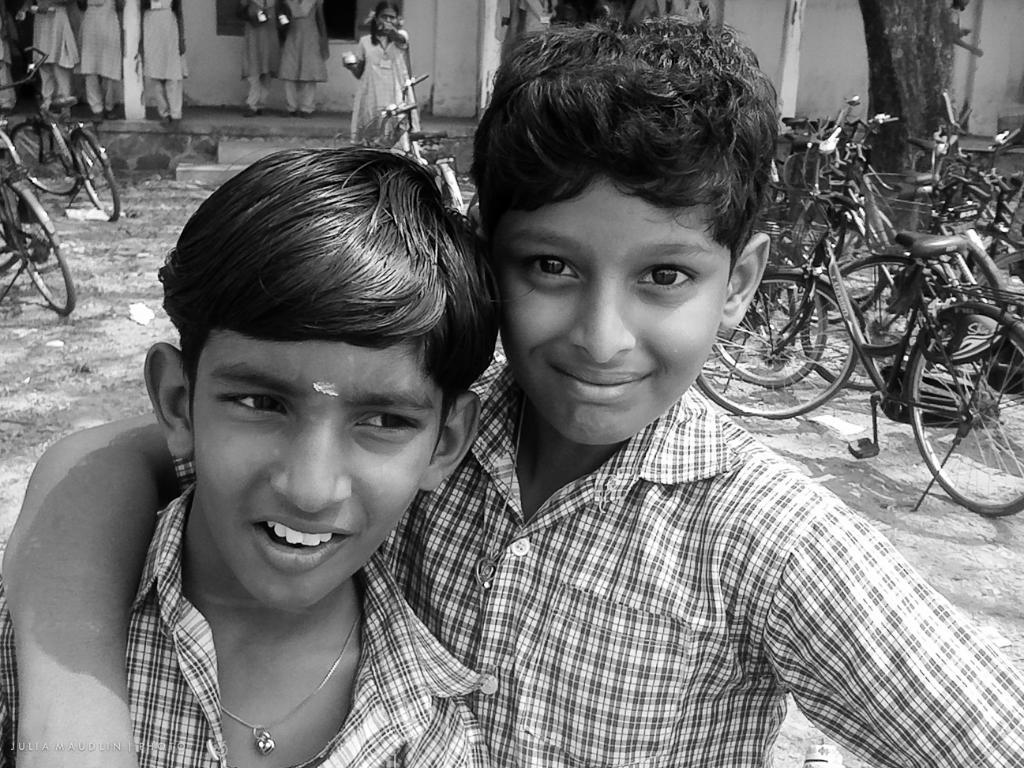What is the color scheme of the image? The image is black and white. What can be seen in the background of the image? There is a wall and people standing in the background of the image. What objects are present in the image? There are bicycles in the image. How many boys are in the image? There are two boys in the image. What are the boys wearing? The boys are wearing uniforms. What expression do the boys have? The boys are smiling. Can you tell me how many ears of corn are visible in the image? There are no ears of corn present in the image. What role does the mother play in the image? There is no mention of a mother in the image, so it is not possible to determine her role. 